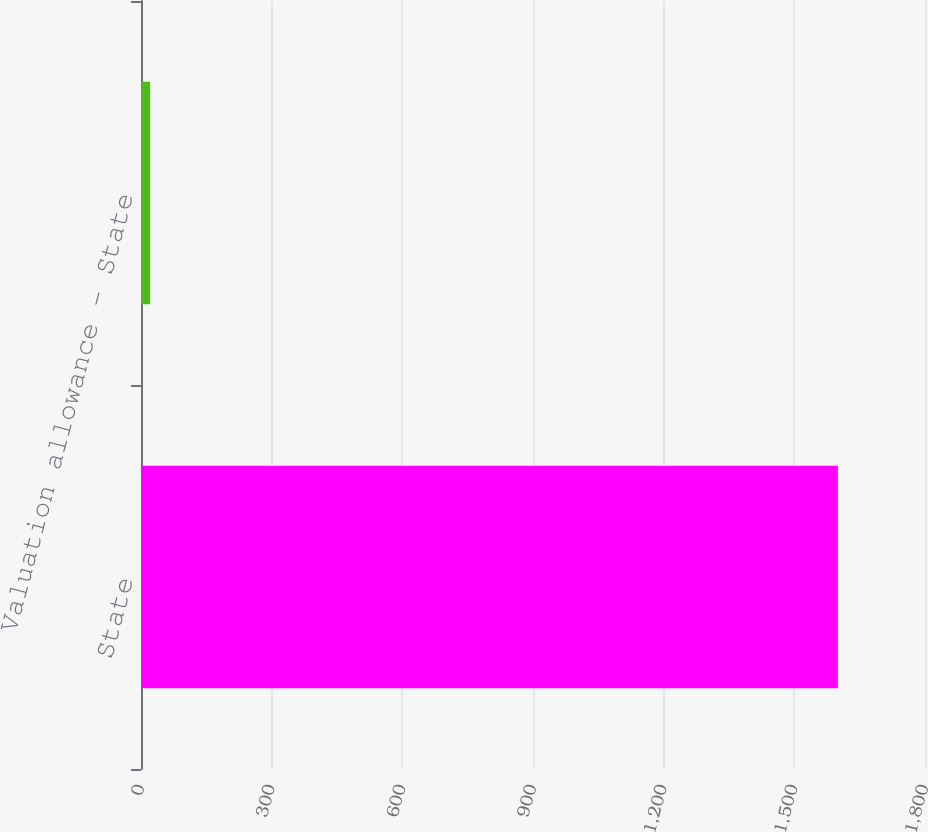Convert chart to OTSL. <chart><loc_0><loc_0><loc_500><loc_500><bar_chart><fcel>State<fcel>Valuation allowance - State<nl><fcel>1600<fcel>21<nl></chart> 